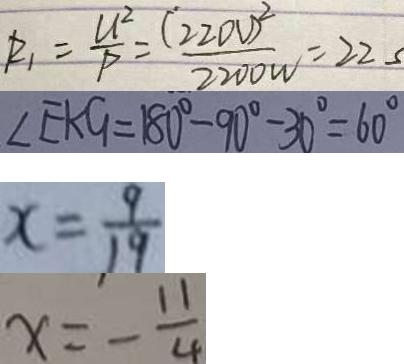Convert formula to latex. <formula><loc_0><loc_0><loc_500><loc_500>R _ { 1 } = \frac { U ^ { 2 } } { P } = \frac { ( 2 2 0 V ) ^ { 2 } } { 2 2 0 0 w } = 2 2 s 
 \angle E A G = 1 8 0 ^ { \circ } - 9 0 ^ { \circ } - 3 0 ^ { \circ } = 6 0 ^ { \circ } 
 x = \frac { 9 } { 1 9 } 
 x = - \frac { 1 1 } { 4 }</formula> 